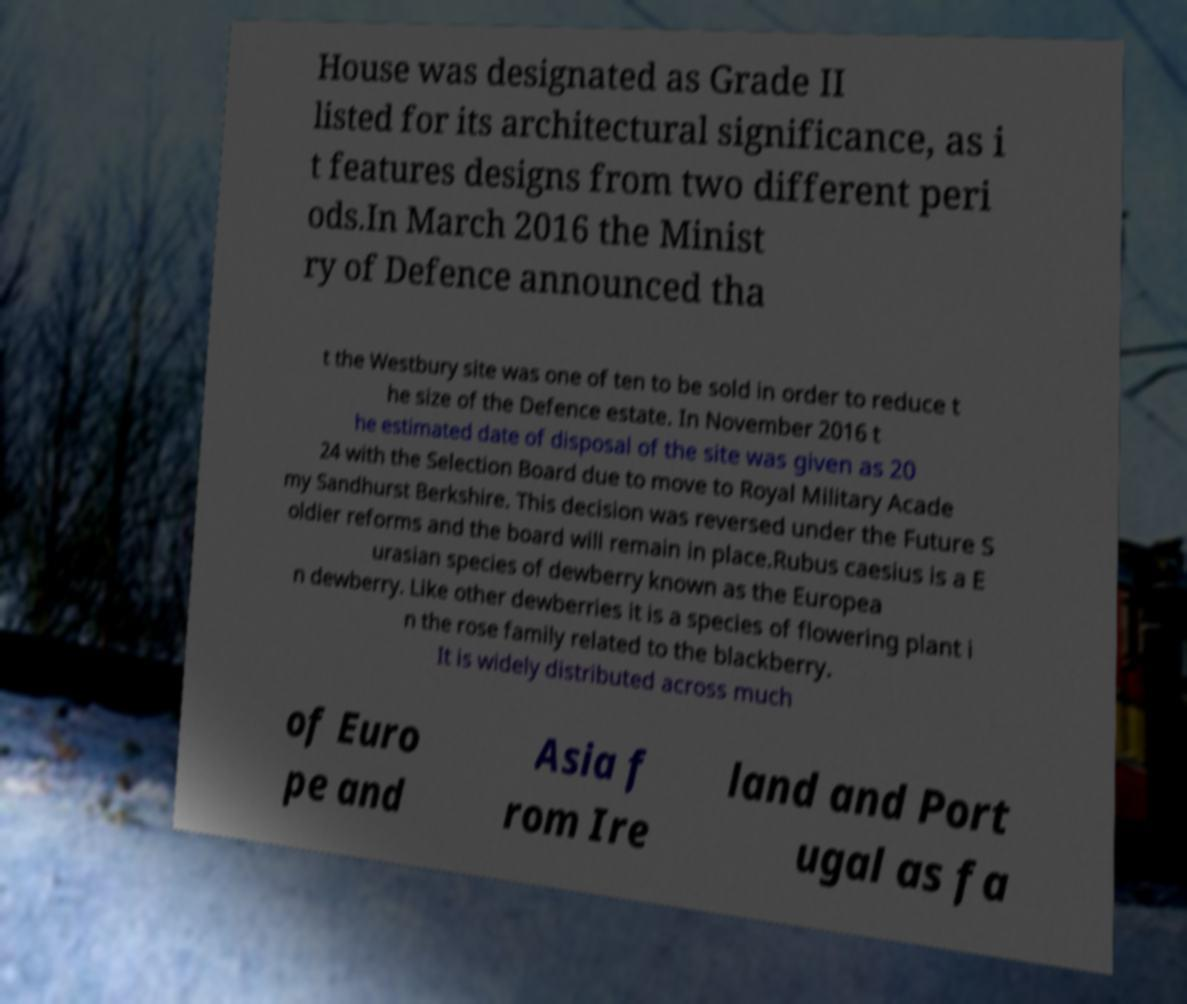Can you accurately transcribe the text from the provided image for me? House was designated as Grade II listed for its architectural significance, as i t features designs from two different peri ods.In March 2016 the Minist ry of Defence announced tha t the Westbury site was one of ten to be sold in order to reduce t he size of the Defence estate. In November 2016 t he estimated date of disposal of the site was given as 20 24 with the Selection Board due to move to Royal Military Acade my Sandhurst Berkshire. This decision was reversed under the Future S oldier reforms and the board will remain in place.Rubus caesius is a E urasian species of dewberry known as the Europea n dewberry. Like other dewberries it is a species of flowering plant i n the rose family related to the blackberry. It is widely distributed across much of Euro pe and Asia f rom Ire land and Port ugal as fa 